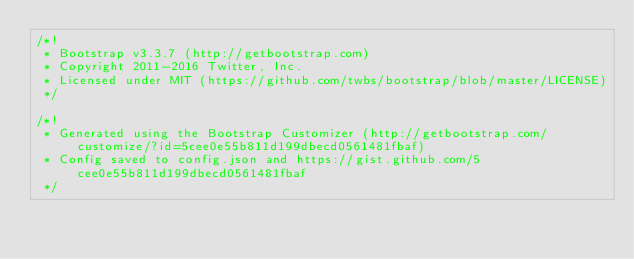<code> <loc_0><loc_0><loc_500><loc_500><_JavaScript_>/*!
 * Bootstrap v3.3.7 (http://getbootstrap.com)
 * Copyright 2011-2016 Twitter, Inc.
 * Licensed under MIT (https://github.com/twbs/bootstrap/blob/master/LICENSE)
 */

/*!
 * Generated using the Bootstrap Customizer (http://getbootstrap.com/customize/?id=5cee0e55b811d199dbecd0561481fbaf)
 * Config saved to config.json and https://gist.github.com/5cee0e55b811d199dbecd0561481fbaf
 */</code> 